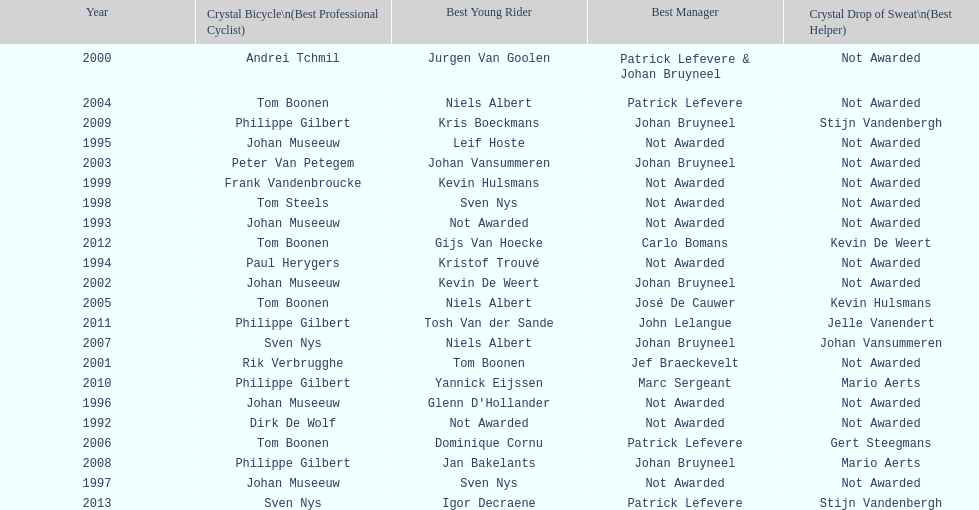Who has won the most best young rider awards? Niels Albert. 